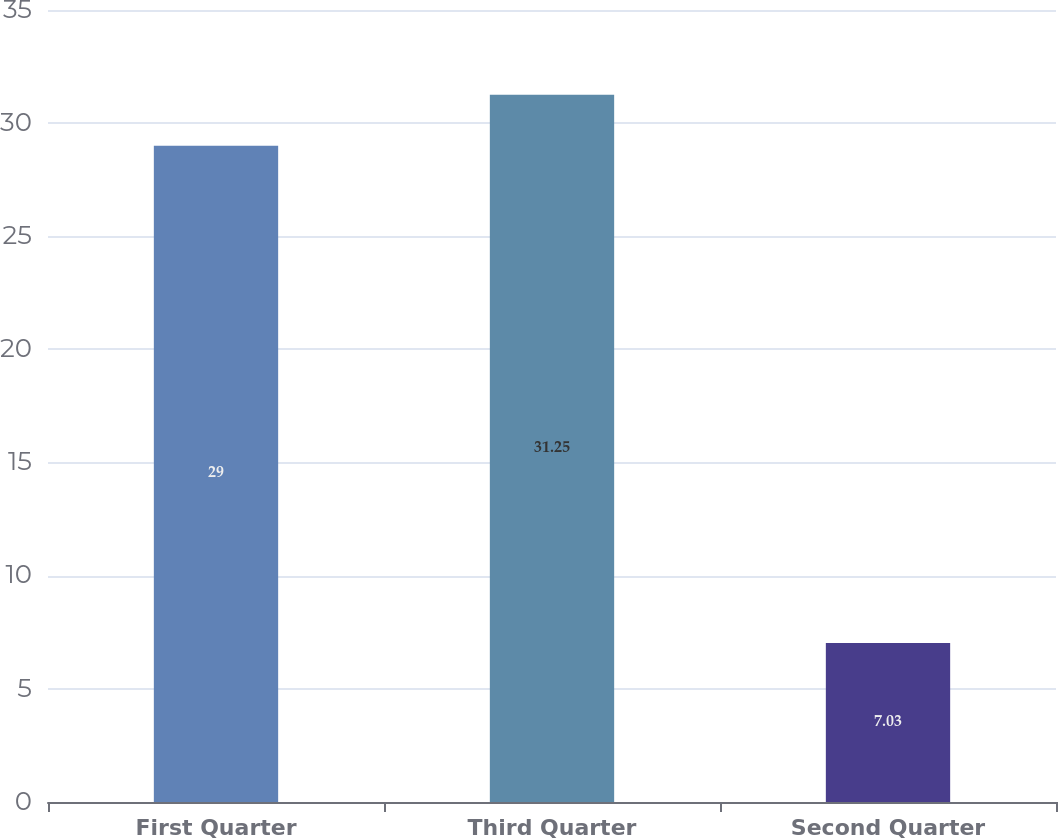Convert chart to OTSL. <chart><loc_0><loc_0><loc_500><loc_500><bar_chart><fcel>First Quarter<fcel>Third Quarter<fcel>Second Quarter<nl><fcel>29<fcel>31.25<fcel>7.03<nl></chart> 